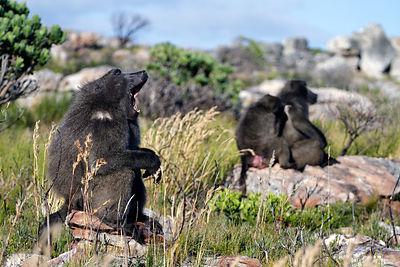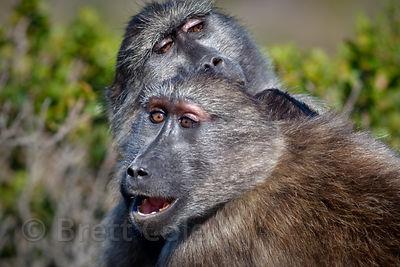The first image is the image on the left, the second image is the image on the right. Given the left and right images, does the statement "Some chimpanzees are walking." hold true? Answer yes or no. No. The first image is the image on the left, the second image is the image on the right. Analyze the images presented: Is the assertion "At least two animals are huddled together." valid? Answer yes or no. Yes. 